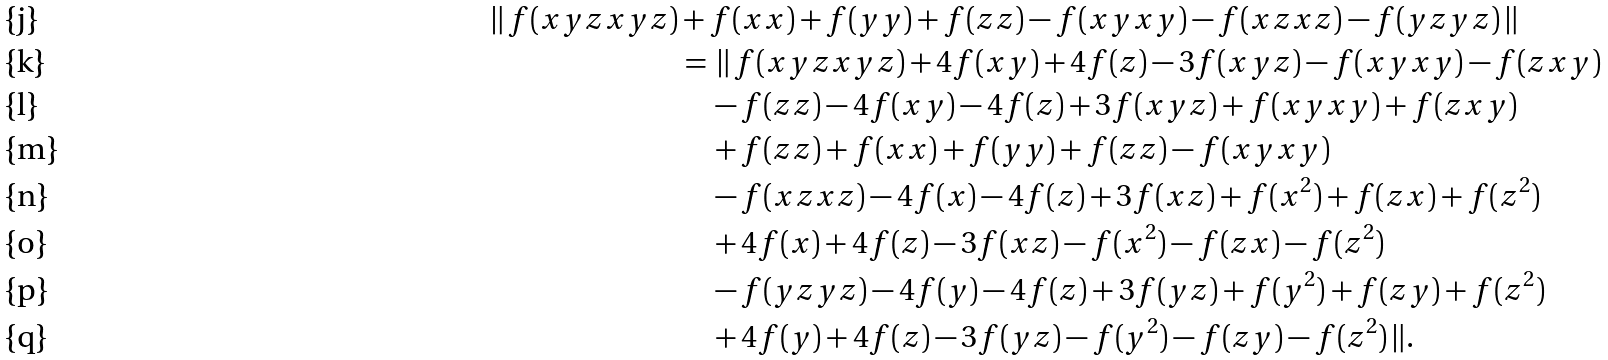Convert formula to latex. <formula><loc_0><loc_0><loc_500><loc_500>\| \, f ( x y z x y z ) & + f ( x x ) + f ( y y ) + f ( z z ) - f ( x y x y ) - f ( x z x z ) - f ( y z y z ) \, \| \\ & = \, \| \, f ( x y z x y z ) + 4 f ( x y ) + 4 f ( z ) - 3 f ( x y z ) - f ( x y x y ) - f ( z x y ) \\ & \quad - f ( z z ) - 4 f ( x y ) - 4 f ( z ) + 3 f ( x y z ) + f ( x y x y ) + f ( z x y ) \\ & \quad + f ( z z ) + f ( x x ) + f ( y y ) + f ( z z ) - f ( x y x y ) \\ & \quad - f ( x z x z ) - 4 f ( x ) - 4 f ( z ) + 3 f ( x z ) + f ( x ^ { 2 } ) + f ( z x ) + f ( z ^ { 2 } ) \\ & \quad + 4 f ( x ) + 4 f ( z ) - 3 f ( x z ) - f ( x ^ { 2 } ) - f ( z x ) - f ( z ^ { 2 } ) \\ & \quad - f ( y z y z ) - 4 f ( y ) - 4 f ( z ) + 3 f ( y z ) + f ( y ^ { 2 } ) + f ( z y ) + f ( z ^ { 2 } ) \\ & \quad + 4 f ( y ) + 4 f ( z ) - 3 f ( y z ) - f ( y ^ { 2 } ) - f ( z y ) - f ( z ^ { 2 } ) \, \| .</formula> 